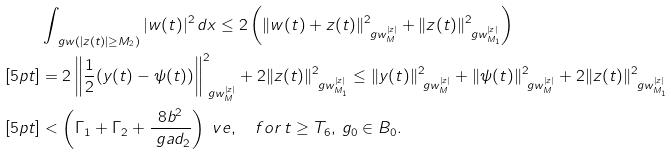<formula> <loc_0><loc_0><loc_500><loc_500>& \int _ { \ g w ( | z ( t ) | \geq M _ { 2 } ) } | w ( t ) | ^ { 2 } \, d x \leq 2 \left ( \| w ( t ) + z ( t ) \| _ { \ g w _ { M } ^ { | z | } } ^ { 2 } + \| z ( t ) \| _ { \ g w _ { M _ { 1 } } ^ { | z | } } ^ { 2 } \right ) \\ [ 5 p t ] & = 2 \left \| \frac { 1 } { 2 } ( y ( t ) - \psi ( t ) ) \right \| _ { \ g w _ { M } ^ { | z | } } ^ { 2 } + 2 \| z ( t ) \| _ { \ g w _ { M _ { 1 } } ^ { | z | } } ^ { 2 } \leq \| y ( t ) \| _ { \ g w _ { M } ^ { | z | } } ^ { 2 } + \| \psi ( t ) \| _ { \ g w _ { M } ^ { | z | } } ^ { 2 } + 2 \| z ( t ) \| _ { \ g w _ { M _ { 1 } } ^ { | z | } } ^ { 2 } \\ [ 5 p t ] & < \left ( \Gamma _ { 1 } + \Gamma _ { 2 } + \frac { 8 b ^ { 2 } } { \ g a d _ { 2 } } \right ) \ v e , \quad f o r \, t \geq T _ { 6 } , \, g _ { 0 } \in B _ { 0 } .</formula> 